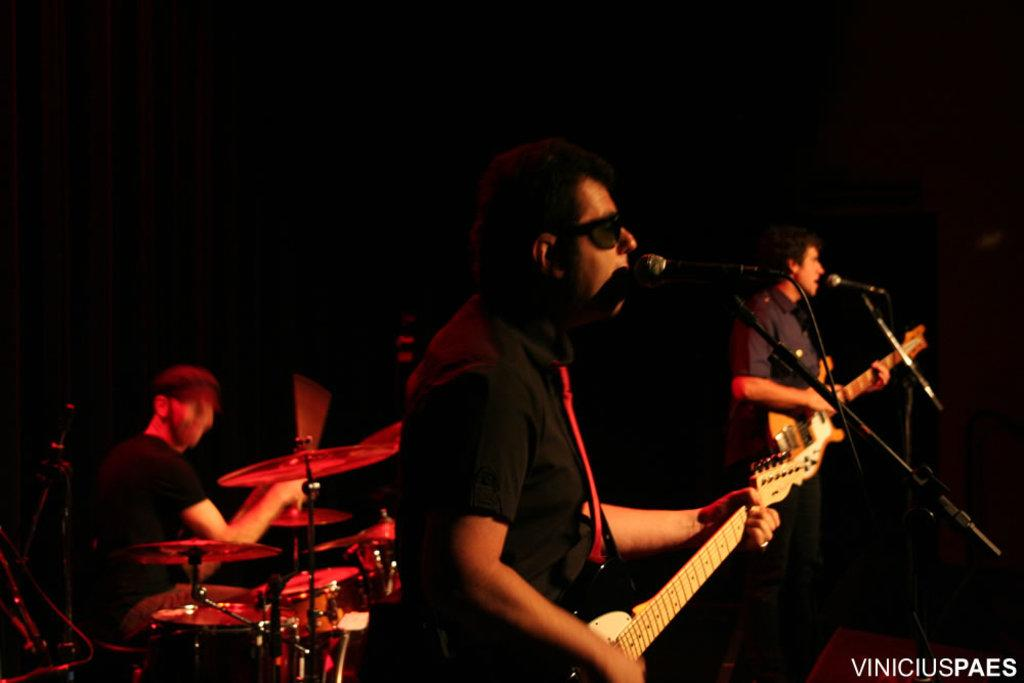What is happening on the stage in the image? There are three members on a stage, with two playing guitars and one playing drums. What equipment do the members have in front of them? All three members have microphones in front of them. What type of chess piece is the drummer playing in the image? There is no chess piece present in the image; the drummer is playing drums. What time is displayed on the clock in the image? There is no clock present in the image. 